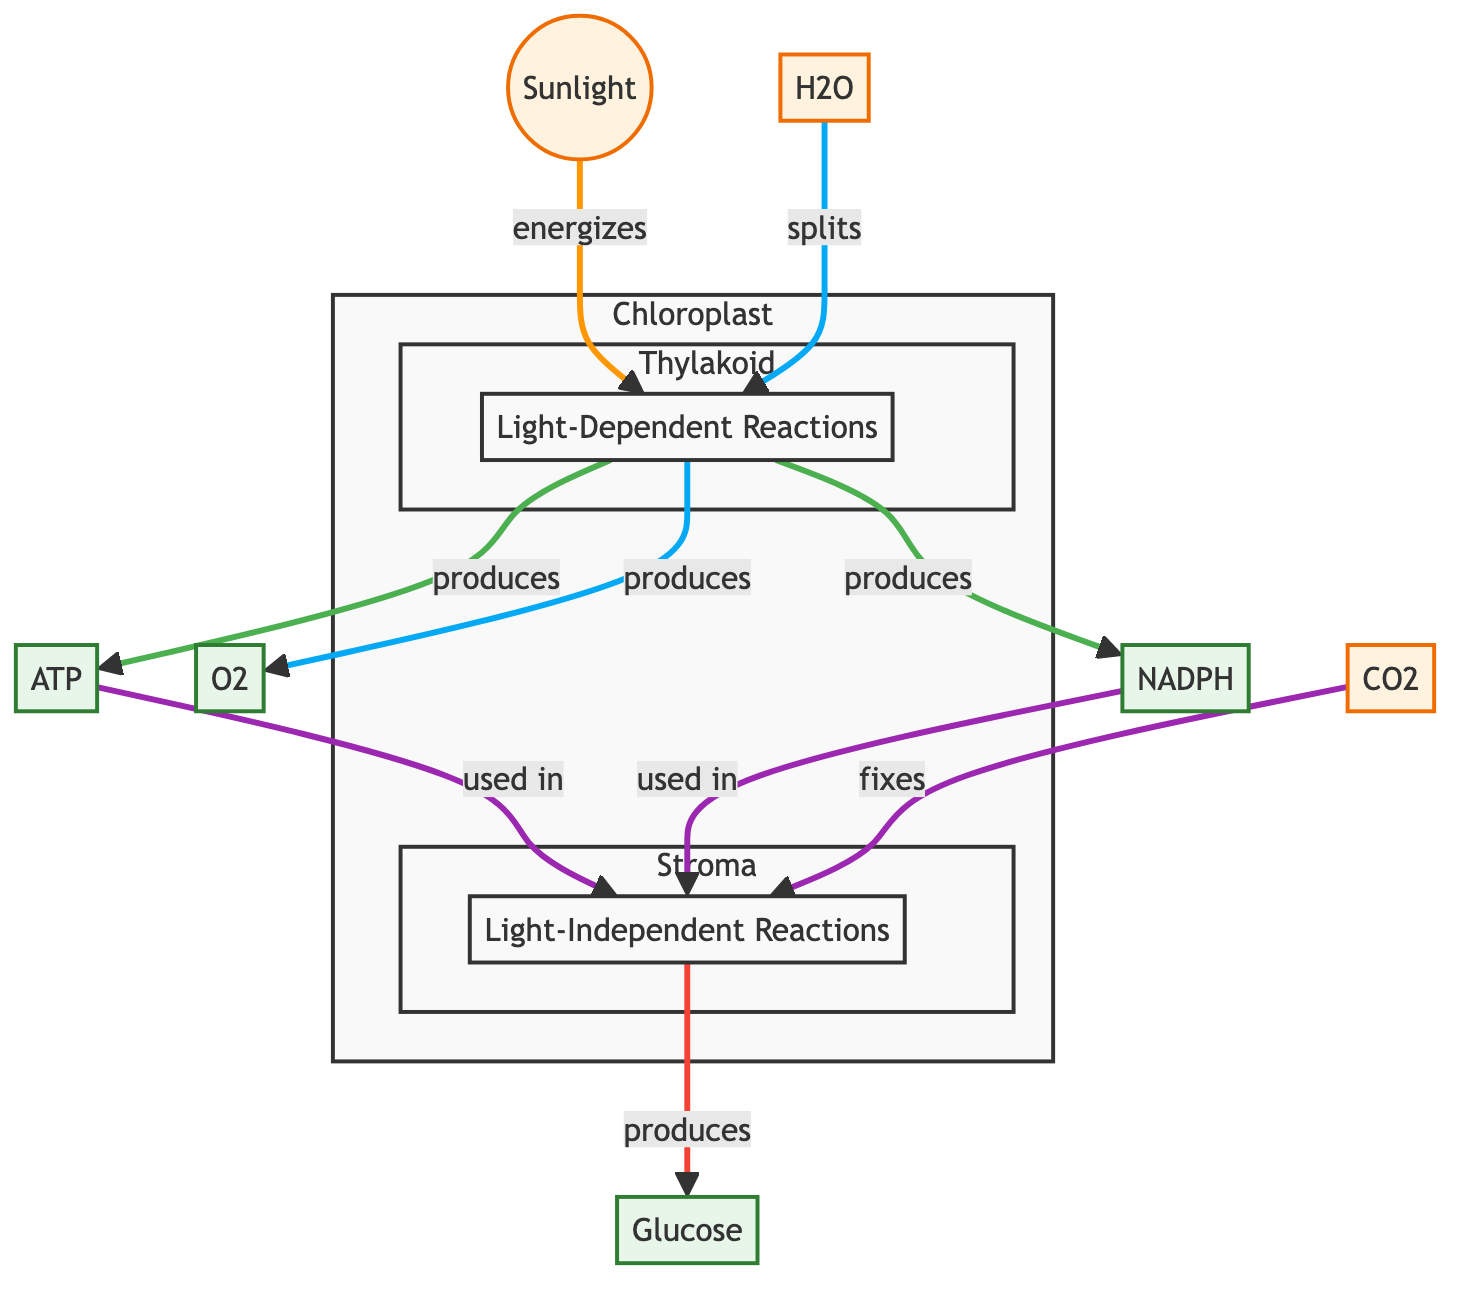What are the three products of the light-dependent reactions? The diagram shows that the light-dependent reactions produce three products: O2, ATP, and NADPH. This information can be found directly connected to the LDR node in the diagram.
Answer: O2, ATP, NADPH Where does carbon dioxide enter the photosynthesis process? According to the diagram, carbon dioxide (CO2) enters the light-independent reactions (LIR) as a reactant that is fixed during this process. This connection is shown in the flow from the CO2 node to the LIR node.
Answer: Light-Independent Reactions How many reactants are involved in the light-dependent reactions? The flowchart indicates that there are two reactants involved in the light-dependent reactions: Sunlight and H2O. Both of these nodes directly link to the LDR node in the diagram.
Answer: 2 What is the purpose of ATP in the photosynthesis process? The diagram illustrates that ATP is used in the light-independent reactions (LIR) after being produced in the light-dependent reactions (LDR). This usage is outlined by the directional flow from the ATP node to the LIR node.
Answer: Energy source How does water contribute to the light-dependent reactions? The diagram states that water (H2O) splits during the light-dependent reactions (LDR), which leads to the production of O2, ATP, and NADPH. The connection is made through the labeling of the split process within the LDR node.
Answer: Splits Which process produces glucose? In the diagram, the glucose is produced in the light-independent reactions (LIR) as indicated by the directional flow from the LIR node to the Glucose product node, showing that glucose is a result of the LIR.
Answer: Light-Independent Reactions How does light energy impact the photosynthesis process? The diagram shows that light energy from sunlight energizes the light-dependent reactions (LDR), which is represented by the arrow indicating the relationship between sunlight and LDR. This energy is essential for initiating the process.
Answer: Energizes LDR Which molecule is released as a byproduct of the light-dependent reactions? Based on the diagram, oxygen (O2) is identified as a product that is released during the light-dependent reactions (LDR). This is clearly stated in the flow that leads from the LDR node to the O2 node.
Answer: Oxygen 